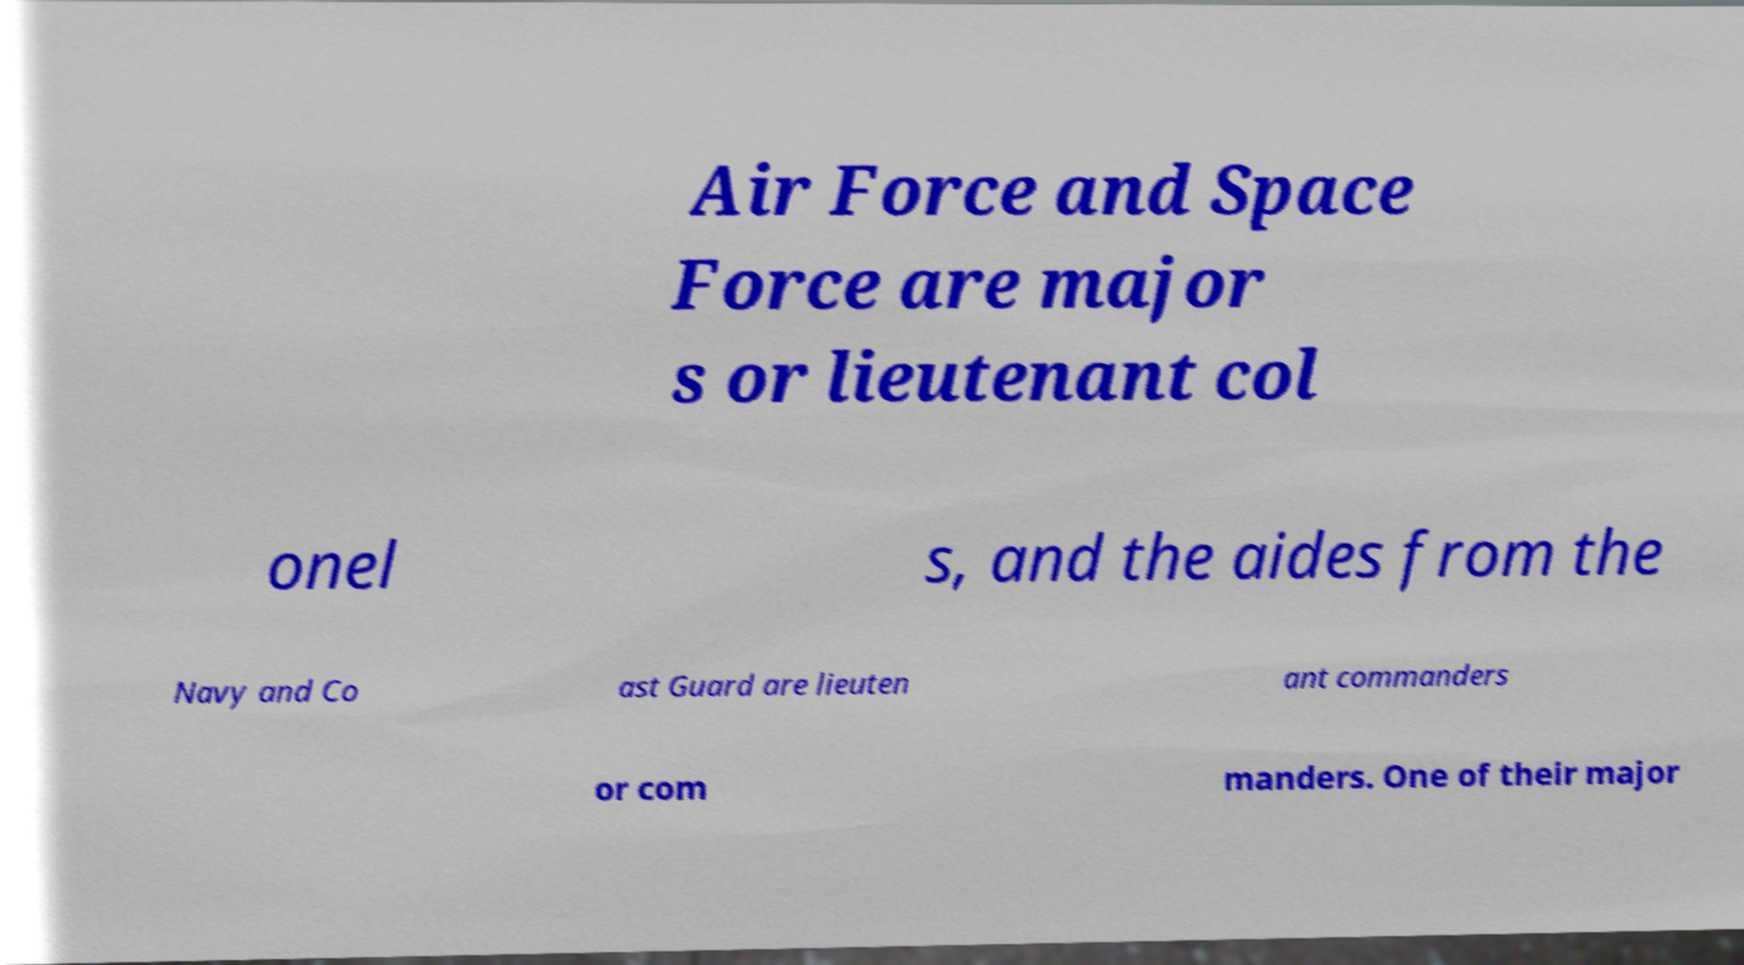Could you assist in decoding the text presented in this image and type it out clearly? Air Force and Space Force are major s or lieutenant col onel s, and the aides from the Navy and Co ast Guard are lieuten ant commanders or com manders. One of their major 